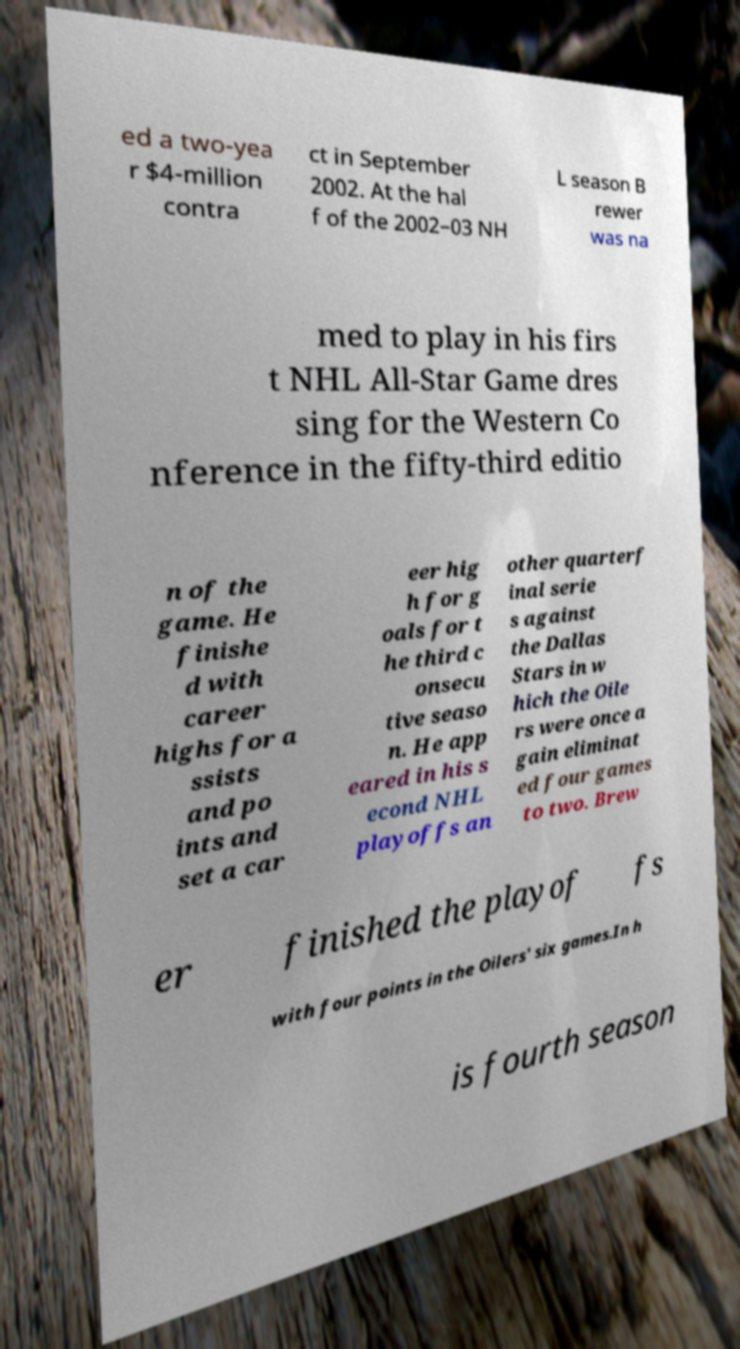I need the written content from this picture converted into text. Can you do that? ed a two-yea r $4-million contra ct in September 2002. At the hal f of the 2002–03 NH L season B rewer was na med to play in his firs t NHL All-Star Game dres sing for the Western Co nference in the fifty-third editio n of the game. He finishe d with career highs for a ssists and po ints and set a car eer hig h for g oals for t he third c onsecu tive seaso n. He app eared in his s econd NHL playoffs an other quarterf inal serie s against the Dallas Stars in w hich the Oile rs were once a gain eliminat ed four games to two. Brew er finished the playof fs with four points in the Oilers' six games.In h is fourth season 